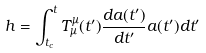Convert formula to latex. <formula><loc_0><loc_0><loc_500><loc_500>h = \int _ { t _ { c } } ^ { t } T ^ { \mu } _ { \mu } ( t ^ { \prime } ) \frac { d a ( t ^ { \prime } ) } { d t ^ { \prime } } a ( t ^ { \prime } ) d t ^ { \prime }</formula> 